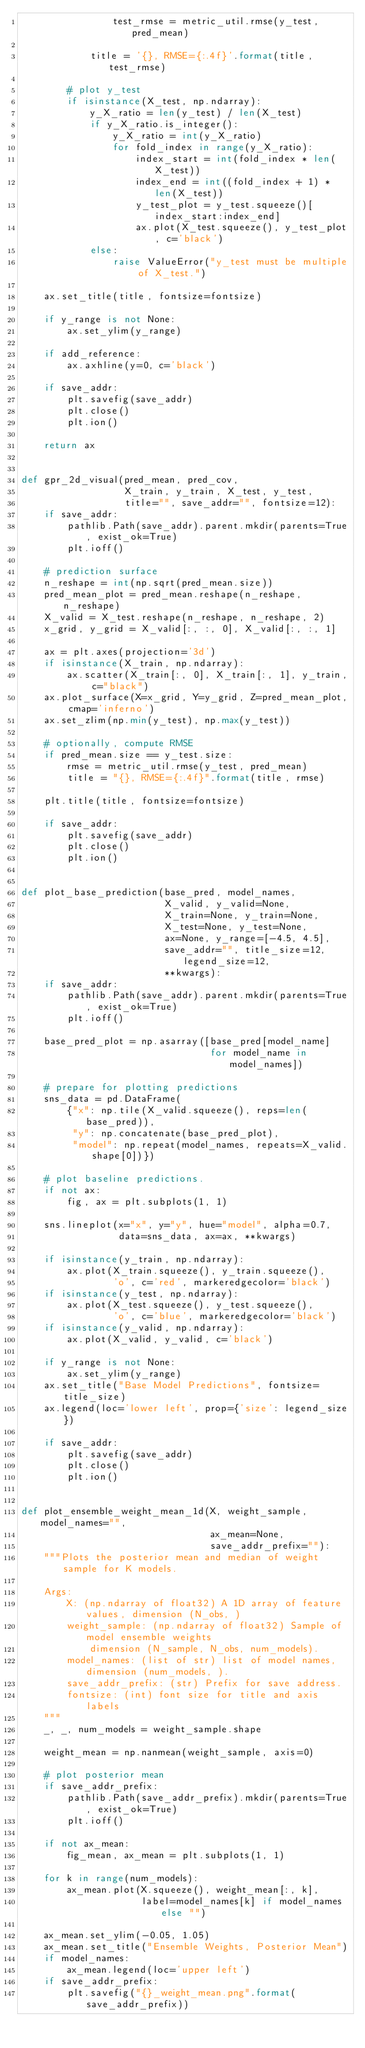Convert code to text. <code><loc_0><loc_0><loc_500><loc_500><_Python_>                test_rmse = metric_util.rmse(y_test, pred_mean)

            title = '{}, RMSE={:.4f}'.format(title, test_rmse)

        # plot y_test
        if isinstance(X_test, np.ndarray):
            y_X_ratio = len(y_test) / len(X_test)
            if y_X_ratio.is_integer():
                y_X_ratio = int(y_X_ratio)
                for fold_index in range(y_X_ratio):
                    index_start = int(fold_index * len(X_test))
                    index_end = int((fold_index + 1) * len(X_test))
                    y_test_plot = y_test.squeeze()[index_start:index_end]
                    ax.plot(X_test.squeeze(), y_test_plot, c='black')
            else:
                raise ValueError("y_test must be multiple of X_test.")

    ax.set_title(title, fontsize=fontsize)

    if y_range is not None:
        ax.set_ylim(y_range)

    if add_reference:
        ax.axhline(y=0, c='black')

    if save_addr:
        plt.savefig(save_addr)
        plt.close()
        plt.ion()

    return ax


def gpr_2d_visual(pred_mean, pred_cov,
                  X_train, y_train, X_test, y_test,
                  title="", save_addr="", fontsize=12):
    if save_addr:
        pathlib.Path(save_addr).parent.mkdir(parents=True, exist_ok=True)
        plt.ioff()

    # prediction surface
    n_reshape = int(np.sqrt(pred_mean.size))
    pred_mean_plot = pred_mean.reshape(n_reshape, n_reshape)
    X_valid = X_test.reshape(n_reshape, n_reshape, 2)
    x_grid, y_grid = X_valid[:, :, 0], X_valid[:, :, 1]

    ax = plt.axes(projection='3d')
    if isinstance(X_train, np.ndarray):
        ax.scatter(X_train[:, 0], X_train[:, 1], y_train, c="black")
    ax.plot_surface(X=x_grid, Y=y_grid, Z=pred_mean_plot, cmap='inferno')
    ax.set_zlim(np.min(y_test), np.max(y_test))

    # optionally, compute RMSE
    if pred_mean.size == y_test.size:
        rmse = metric_util.rmse(y_test, pred_mean)
        title = "{}, RMSE={:.4f}".format(title, rmse)

    plt.title(title, fontsize=fontsize)

    if save_addr:
        plt.savefig(save_addr)
        plt.close()
        plt.ion()


def plot_base_prediction(base_pred, model_names,
                         X_valid, y_valid=None,
                         X_train=None, y_train=None,
                         X_test=None, y_test=None,
                         ax=None, y_range=[-4.5, 4.5],
                         save_addr="", title_size=12, legend_size=12,
                         **kwargs):
    if save_addr:
        pathlib.Path(save_addr).parent.mkdir(parents=True, exist_ok=True)
        plt.ioff()

    base_pred_plot = np.asarray([base_pred[model_name]
                                 for model_name in model_names])

    # prepare for plotting predictions
    sns_data = pd.DataFrame(
        {"x": np.tile(X_valid.squeeze(), reps=len(base_pred)),
         "y": np.concatenate(base_pred_plot),
         "model": np.repeat(model_names, repeats=X_valid.shape[0])})

    # plot baseline predictions.
    if not ax:
        fig, ax = plt.subplots(1, 1)

    sns.lineplot(x="x", y="y", hue="model", alpha=0.7,
                 data=sns_data, ax=ax, **kwargs)

    if isinstance(y_train, np.ndarray):
        ax.plot(X_train.squeeze(), y_train.squeeze(),
                'o', c='red', markeredgecolor='black')
    if isinstance(y_test, np.ndarray):
        ax.plot(X_test.squeeze(), y_test.squeeze(),
                'o', c='blue', markeredgecolor='black')
    if isinstance(y_valid, np.ndarray):
        ax.plot(X_valid, y_valid, c='black')

    if y_range is not None:
        ax.set_ylim(y_range)
    ax.set_title("Base Model Predictions", fontsize=title_size)
    ax.legend(loc='lower left', prop={'size': legend_size})

    if save_addr:
        plt.savefig(save_addr)
        plt.close()
        plt.ion()


def plot_ensemble_weight_mean_1d(X, weight_sample, model_names="",
                                 ax_mean=None,
                                 save_addr_prefix=""):
    """Plots the posterior mean and median of weight sample for K models.

    Args:
        X: (np.ndarray of float32) A 1D array of feature values, dimension (N_obs, )
        weight_sample: (np.ndarray of float32) Sample of model ensemble weights
            dimension (N_sample, N_obs, num_models).
        model_names: (list of str) list of model names, dimension (num_models, ).
        save_addr_prefix: (str) Prefix for save address.
        fontsize: (int) font size for title and axis labels
    """
    _, _, num_models = weight_sample.shape

    weight_mean = np.nanmean(weight_sample, axis=0)

    # plot posterior mean
    if save_addr_prefix:
        pathlib.Path(save_addr_prefix).mkdir(parents=True, exist_ok=True)
        plt.ioff()

    if not ax_mean:
        fig_mean, ax_mean = plt.subplots(1, 1)

    for k in range(num_models):
        ax_mean.plot(X.squeeze(), weight_mean[:, k],
                     label=model_names[k] if model_names else "")

    ax_mean.set_ylim(-0.05, 1.05)
    ax_mean.set_title("Ensemble Weights, Posterior Mean")
    if model_names:
        ax_mean.legend(loc='upper left')
    if save_addr_prefix:
        plt.savefig("{}_weight_mean.png".format(save_addr_prefix))</code> 